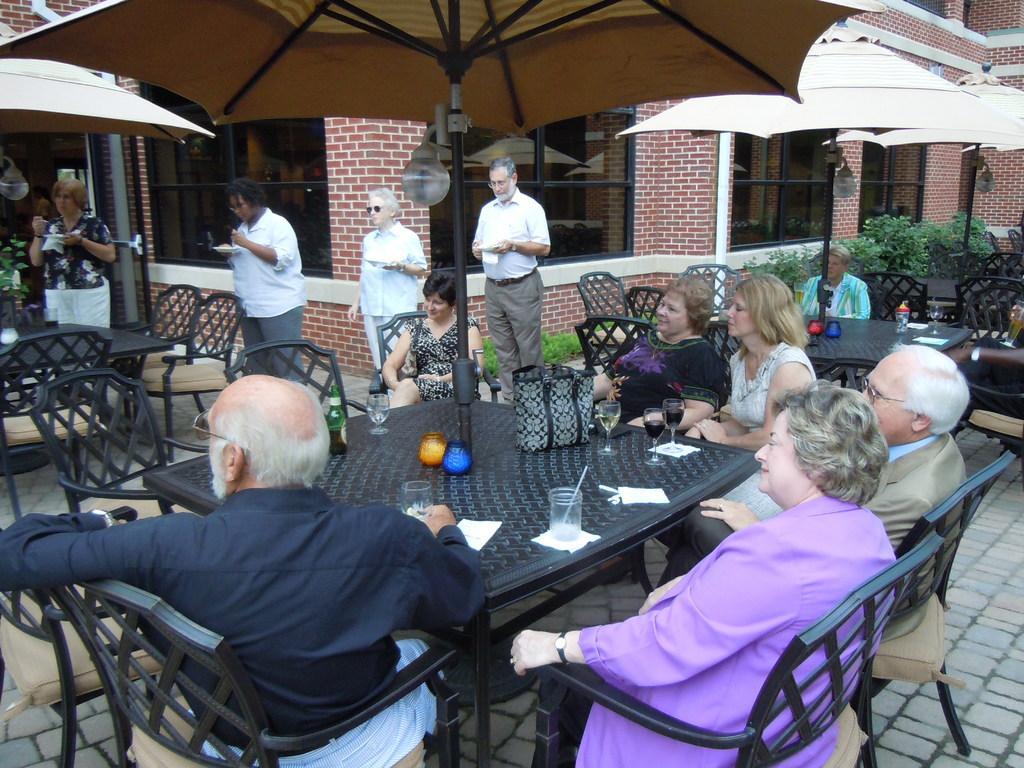How would you summarize this image in a sentence or two? A group of people are sitting on the chairs around a dining table and it's an umbrella in the middle. On the right there are bushes. 